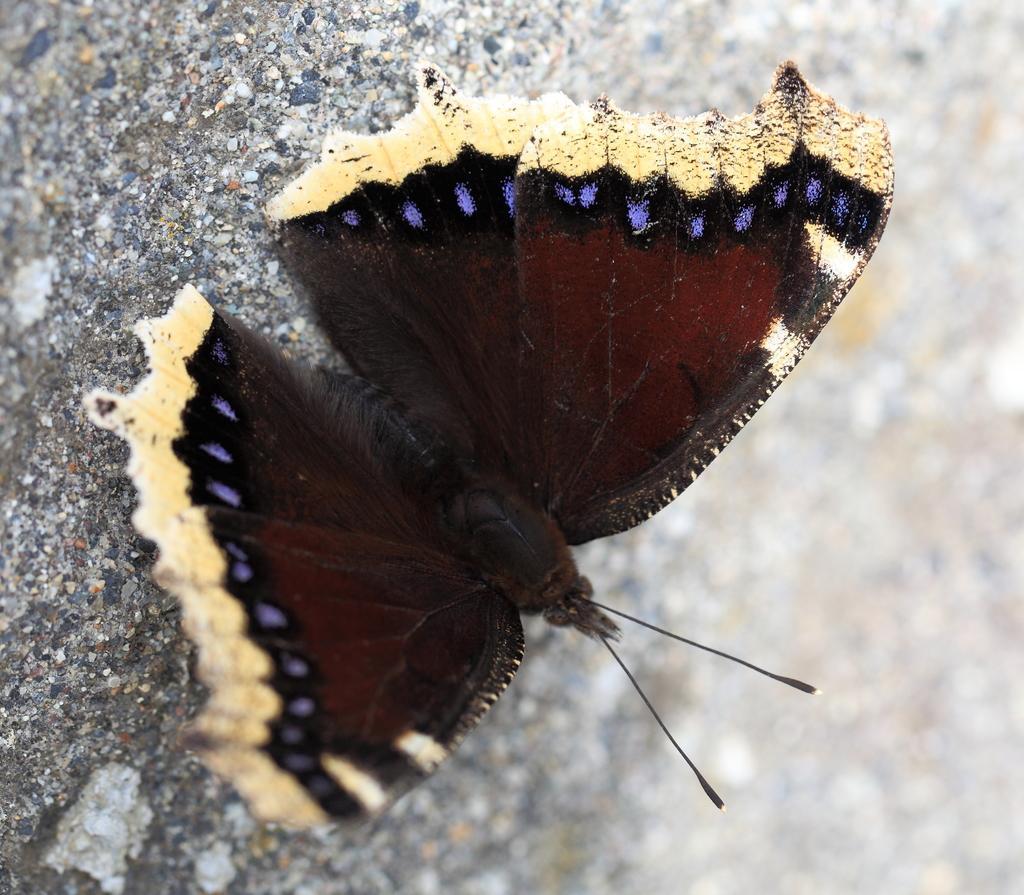Please provide a concise description of this image. In this image we can see a butterfly on the surface. 